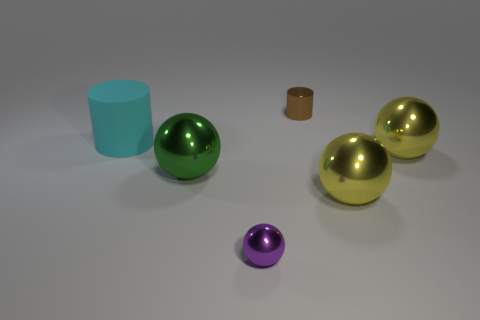There is a thing that is to the left of the green shiny thing; does it have the same size as the purple metallic thing?
Offer a very short reply. No. How many other things are made of the same material as the tiny ball?
Provide a short and direct response. 4. How many cyan things are either small objects or small balls?
Keep it short and to the point. 0. There is a large cyan thing; what number of things are right of it?
Provide a succinct answer. 5. What is the size of the cylinder that is to the left of the cylinder behind the matte thing that is in front of the small shiny cylinder?
Provide a succinct answer. Large. There is a big yellow ball that is behind the big shiny ball that is on the left side of the tiny metal cylinder; are there any big green shiny balls on the right side of it?
Provide a succinct answer. No. Is the number of large yellow spheres greater than the number of large things?
Provide a succinct answer. No. What color is the big sphere in front of the green object?
Ensure brevity in your answer.  Yellow. Are there more tiny cylinders behind the tiny brown object than red rubber things?
Provide a short and direct response. No. Is the material of the large cyan cylinder the same as the tiny brown cylinder?
Make the answer very short. No. 